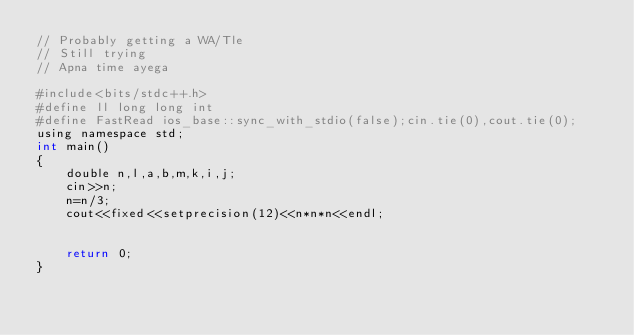Convert code to text. <code><loc_0><loc_0><loc_500><loc_500><_Awk_>// Probably getting a WA/Tle
// Still trying
// Apna time ayega

#include<bits/stdc++.h>
#define ll long long int
#define FastRead ios_base::sync_with_stdio(false);cin.tie(0),cout.tie(0);
using namespace std;
int main()
{
    double n,l,a,b,m,k,i,j;
    cin>>n;
    n=n/3;
    cout<<fixed<<setprecision(12)<<n*n*n<<endl;


    return 0;
}
</code> 